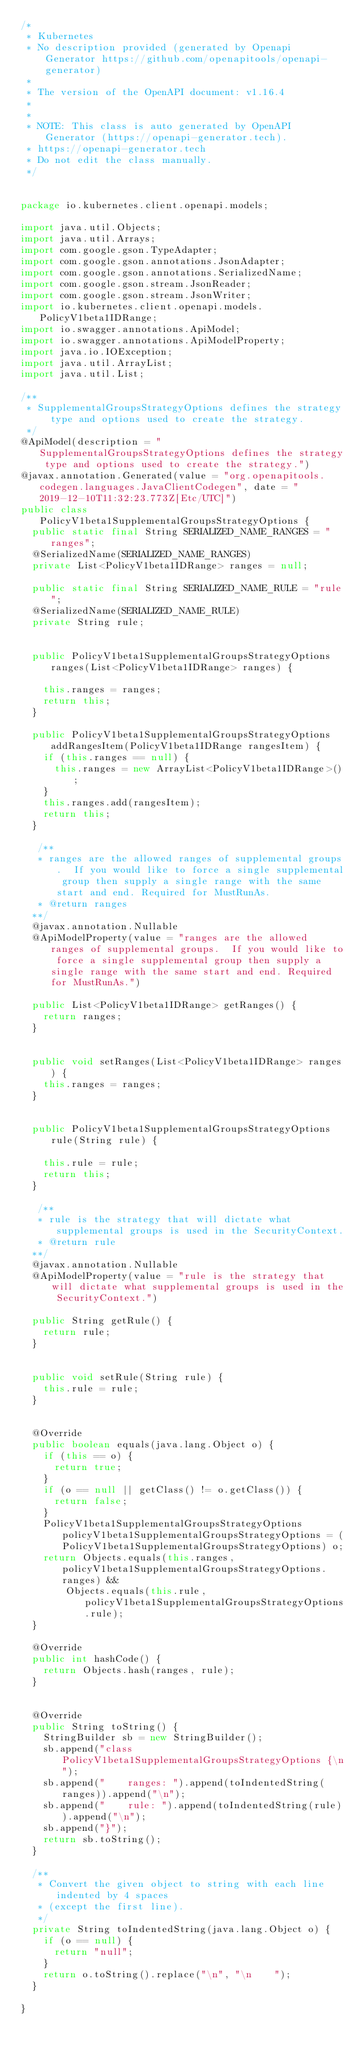Convert code to text. <code><loc_0><loc_0><loc_500><loc_500><_Java_>/*
 * Kubernetes
 * No description provided (generated by Openapi Generator https://github.com/openapitools/openapi-generator)
 *
 * The version of the OpenAPI document: v1.16.4
 * 
 *
 * NOTE: This class is auto generated by OpenAPI Generator (https://openapi-generator.tech).
 * https://openapi-generator.tech
 * Do not edit the class manually.
 */


package io.kubernetes.client.openapi.models;

import java.util.Objects;
import java.util.Arrays;
import com.google.gson.TypeAdapter;
import com.google.gson.annotations.JsonAdapter;
import com.google.gson.annotations.SerializedName;
import com.google.gson.stream.JsonReader;
import com.google.gson.stream.JsonWriter;
import io.kubernetes.client.openapi.models.PolicyV1beta1IDRange;
import io.swagger.annotations.ApiModel;
import io.swagger.annotations.ApiModelProperty;
import java.io.IOException;
import java.util.ArrayList;
import java.util.List;

/**
 * SupplementalGroupsStrategyOptions defines the strategy type and options used to create the strategy.
 */
@ApiModel(description = "SupplementalGroupsStrategyOptions defines the strategy type and options used to create the strategy.")
@javax.annotation.Generated(value = "org.openapitools.codegen.languages.JavaClientCodegen", date = "2019-12-10T11:32:23.773Z[Etc/UTC]")
public class PolicyV1beta1SupplementalGroupsStrategyOptions {
  public static final String SERIALIZED_NAME_RANGES = "ranges";
  @SerializedName(SERIALIZED_NAME_RANGES)
  private List<PolicyV1beta1IDRange> ranges = null;

  public static final String SERIALIZED_NAME_RULE = "rule";
  @SerializedName(SERIALIZED_NAME_RULE)
  private String rule;


  public PolicyV1beta1SupplementalGroupsStrategyOptions ranges(List<PolicyV1beta1IDRange> ranges) {
    
    this.ranges = ranges;
    return this;
  }

  public PolicyV1beta1SupplementalGroupsStrategyOptions addRangesItem(PolicyV1beta1IDRange rangesItem) {
    if (this.ranges == null) {
      this.ranges = new ArrayList<PolicyV1beta1IDRange>();
    }
    this.ranges.add(rangesItem);
    return this;
  }

   /**
   * ranges are the allowed ranges of supplemental groups.  If you would like to force a single supplemental group then supply a single range with the same start and end. Required for MustRunAs.
   * @return ranges
  **/
  @javax.annotation.Nullable
  @ApiModelProperty(value = "ranges are the allowed ranges of supplemental groups.  If you would like to force a single supplemental group then supply a single range with the same start and end. Required for MustRunAs.")

  public List<PolicyV1beta1IDRange> getRanges() {
    return ranges;
  }


  public void setRanges(List<PolicyV1beta1IDRange> ranges) {
    this.ranges = ranges;
  }


  public PolicyV1beta1SupplementalGroupsStrategyOptions rule(String rule) {
    
    this.rule = rule;
    return this;
  }

   /**
   * rule is the strategy that will dictate what supplemental groups is used in the SecurityContext.
   * @return rule
  **/
  @javax.annotation.Nullable
  @ApiModelProperty(value = "rule is the strategy that will dictate what supplemental groups is used in the SecurityContext.")

  public String getRule() {
    return rule;
  }


  public void setRule(String rule) {
    this.rule = rule;
  }


  @Override
  public boolean equals(java.lang.Object o) {
    if (this == o) {
      return true;
    }
    if (o == null || getClass() != o.getClass()) {
      return false;
    }
    PolicyV1beta1SupplementalGroupsStrategyOptions policyV1beta1SupplementalGroupsStrategyOptions = (PolicyV1beta1SupplementalGroupsStrategyOptions) o;
    return Objects.equals(this.ranges, policyV1beta1SupplementalGroupsStrategyOptions.ranges) &&
        Objects.equals(this.rule, policyV1beta1SupplementalGroupsStrategyOptions.rule);
  }

  @Override
  public int hashCode() {
    return Objects.hash(ranges, rule);
  }


  @Override
  public String toString() {
    StringBuilder sb = new StringBuilder();
    sb.append("class PolicyV1beta1SupplementalGroupsStrategyOptions {\n");
    sb.append("    ranges: ").append(toIndentedString(ranges)).append("\n");
    sb.append("    rule: ").append(toIndentedString(rule)).append("\n");
    sb.append("}");
    return sb.toString();
  }

  /**
   * Convert the given object to string with each line indented by 4 spaces
   * (except the first line).
   */
  private String toIndentedString(java.lang.Object o) {
    if (o == null) {
      return "null";
    }
    return o.toString().replace("\n", "\n    ");
  }

}

</code> 